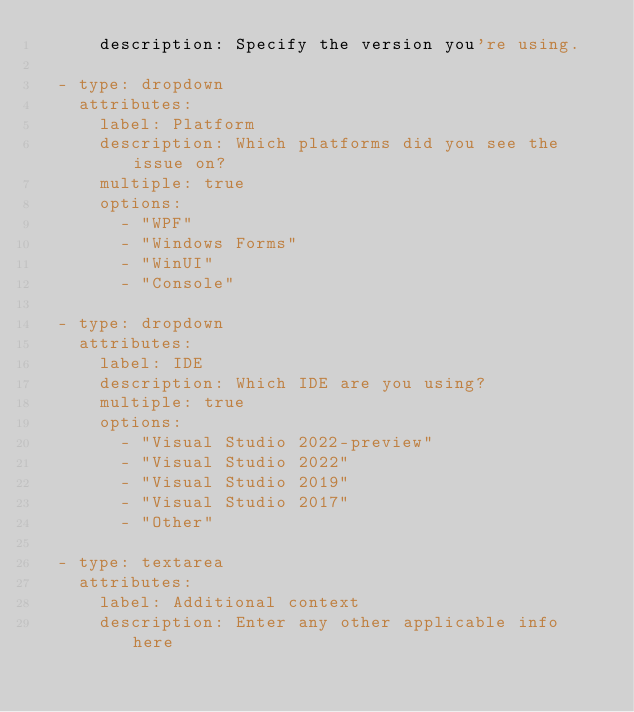Convert code to text. <code><loc_0><loc_0><loc_500><loc_500><_YAML_>      description: Specify the version you're using.
        
  - type: dropdown
    attributes:
      label: Platform
      description: Which platforms did you see the issue on?
      multiple: true
      options:
        - "WPF"
        - "Windows Forms"
        - "WinUI"
        - "Console"
        
  - type: dropdown
    attributes:
      label: IDE
      description: Which IDE are you using?
      multiple: true
      options:
        - "Visual Studio 2022-preview"
        - "Visual Studio 2022"
        - "Visual Studio 2019"
        - "Visual Studio 2017"
        - "Other"

  - type: textarea
    attributes:
      label: Additional context
      description: Enter any other applicable info here
</code> 